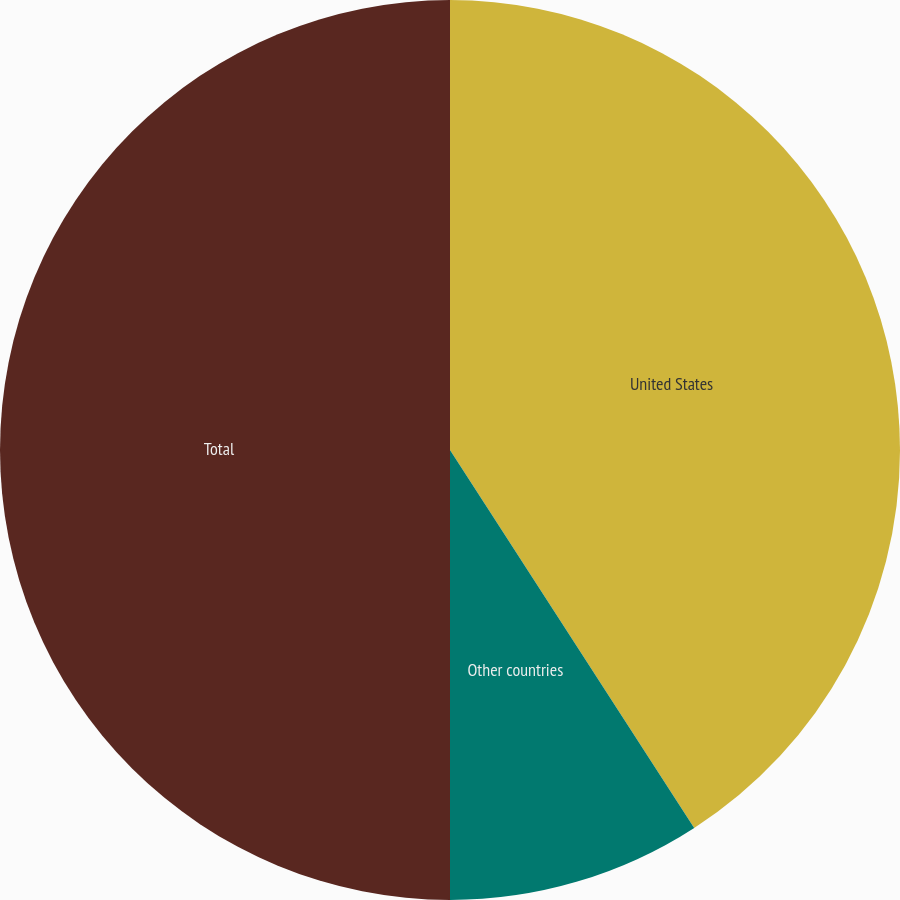Convert chart to OTSL. <chart><loc_0><loc_0><loc_500><loc_500><pie_chart><fcel>United States<fcel>Other countries<fcel>Total<nl><fcel>40.87%<fcel>9.13%<fcel>50.0%<nl></chart> 